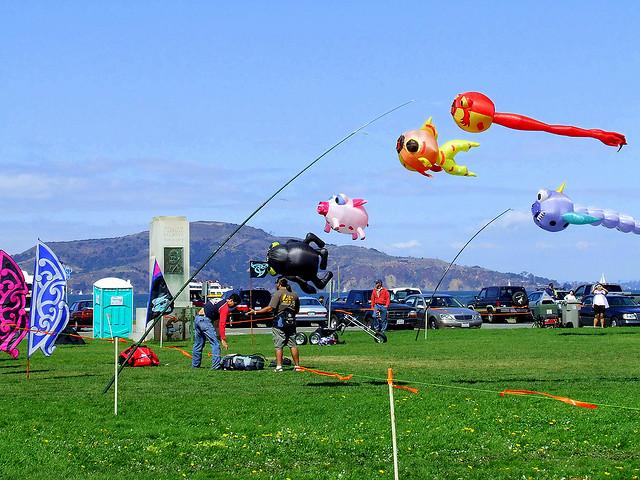Is the wind strong enough to fly kites?
Concise answer only. Yes. What is the  man in the red shirt doing?
Answer briefly. Walking. What kind of animal is the third kite supposed to be?
Write a very short answer. Pig. 